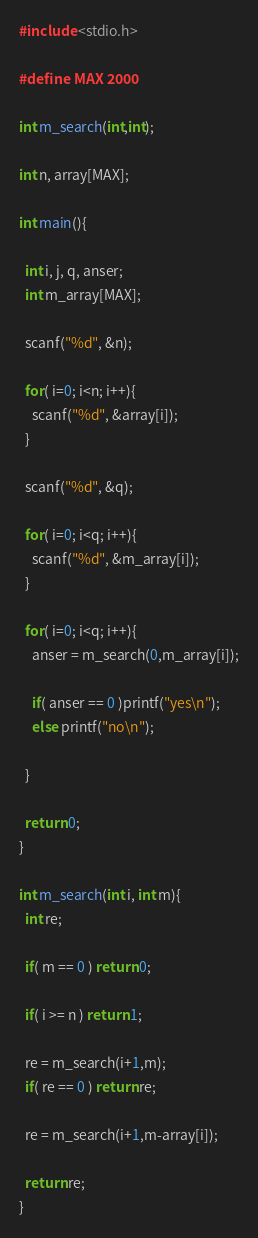Convert code to text. <code><loc_0><loc_0><loc_500><loc_500><_C_>#include <stdio.h>

#define MAX 2000

int m_search(int,int);

int n, array[MAX];

int main(){

  int i, j, q, anser;
  int m_array[MAX];

  scanf("%d", &n);

  for( i=0; i<n; i++){
    scanf("%d", &array[i]);
  }

  scanf("%d", &q);

  for( i=0; i<q; i++){
    scanf("%d", &m_array[i]);
  }

  for( i=0; i<q; i++){
    anser = m_search(0,m_array[i]);

    if( anser == 0 )printf("yes\n");
    else printf("no\n");

  }

  return 0;
}

int m_search(int i, int m){
  int re;

  if( m == 0 ) return 0;

  if( i >= n ) return 1;

  re = m_search(i+1,m);
  if( re == 0 ) return re;

  re = m_search(i+1,m-array[i]);

  return re;
}

</code> 